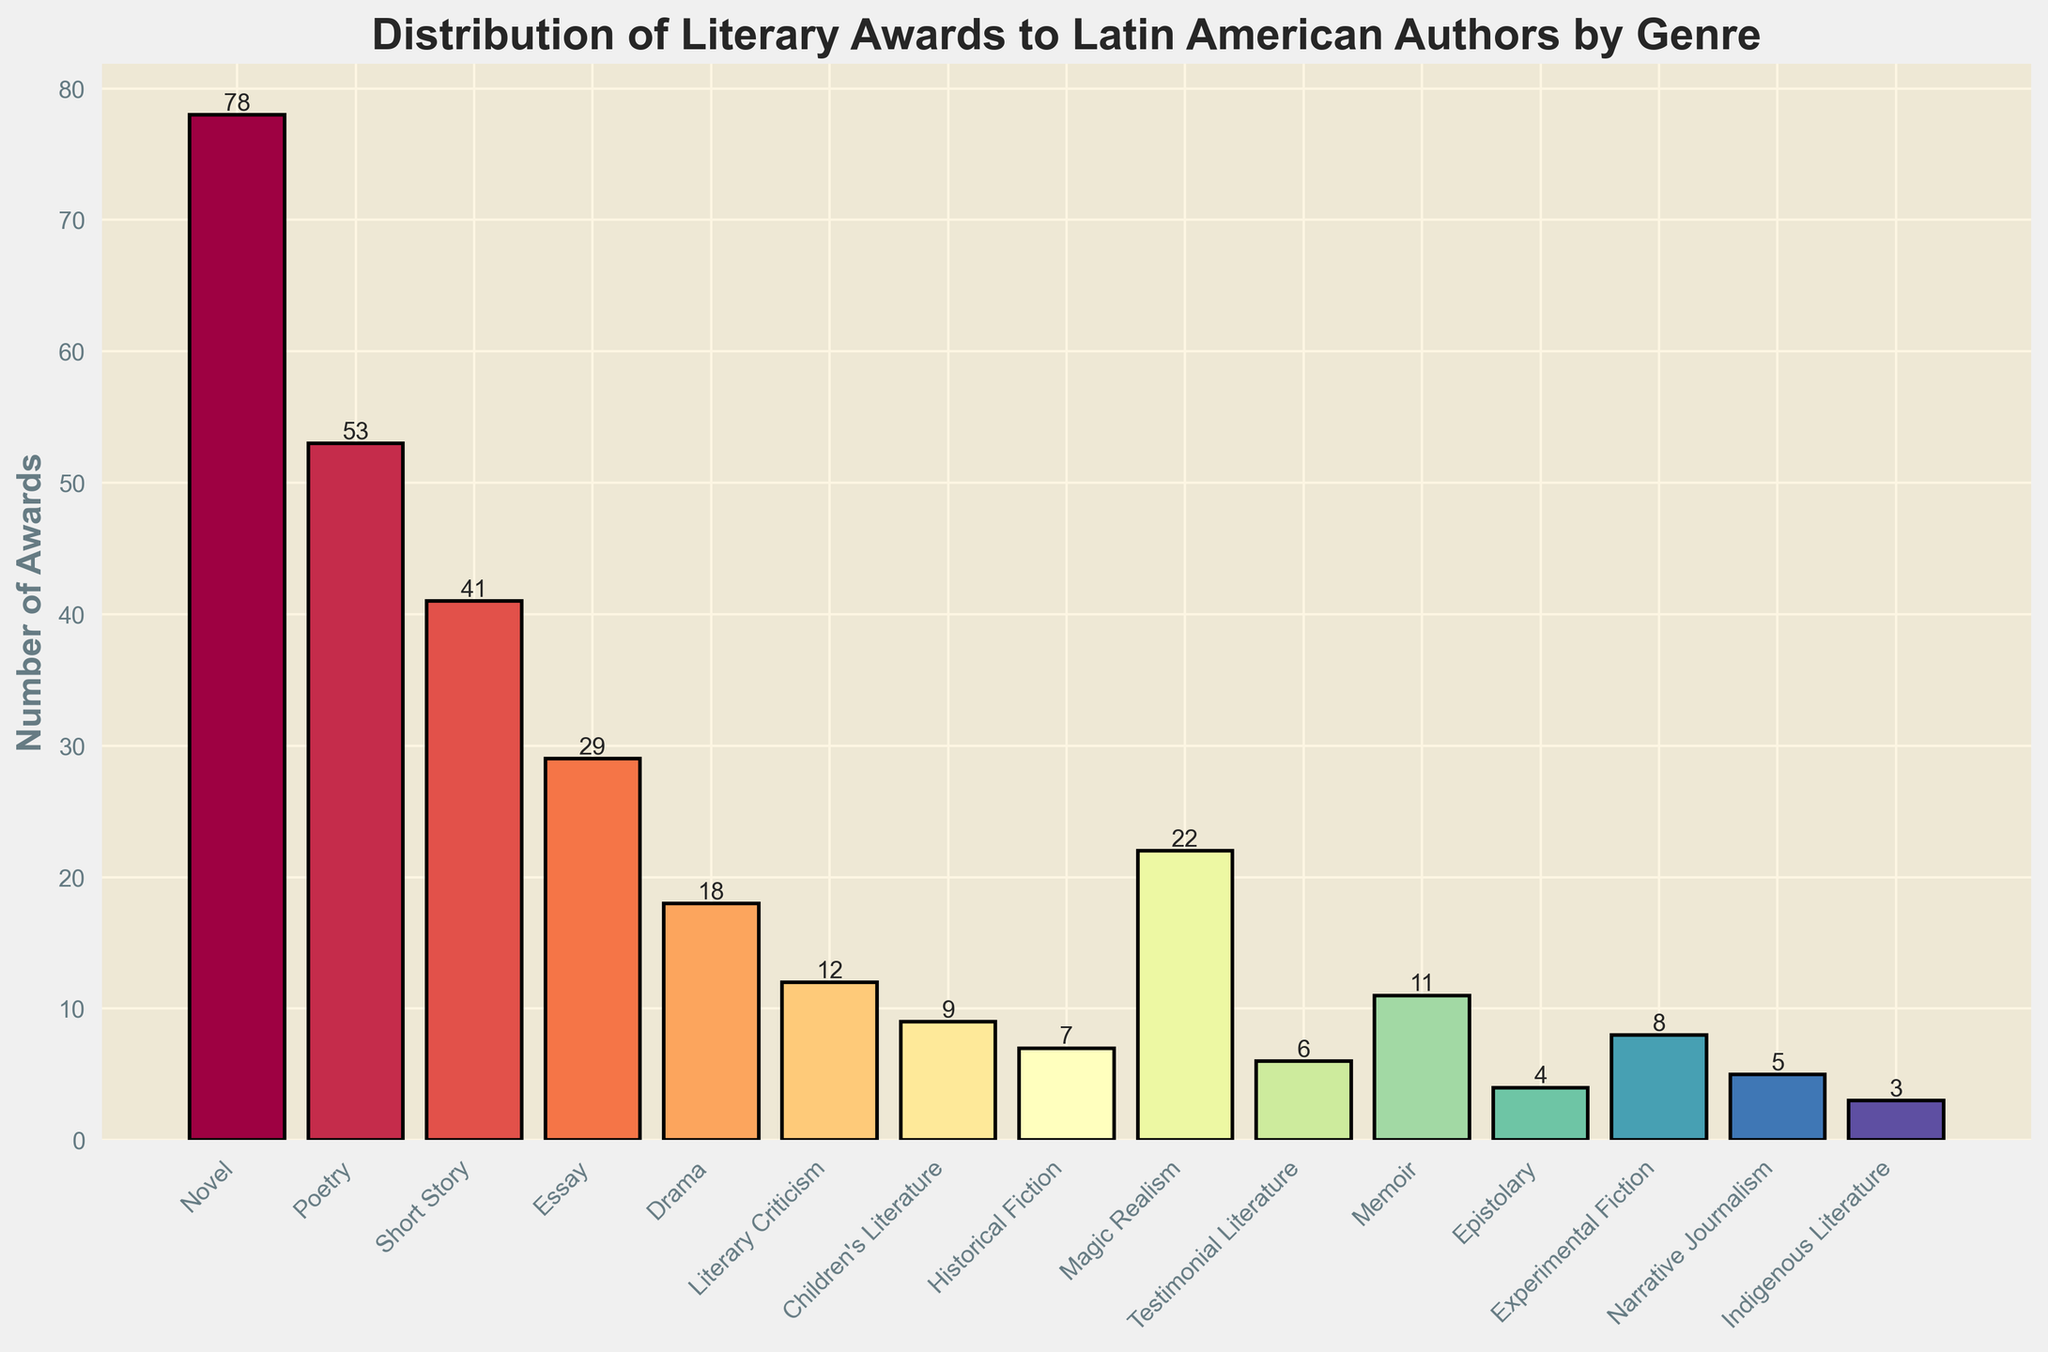What's the genre with the highest number of awards? The tallest bar in the chart represents the genre with the highest number of awards. This bar corresponds to "Novel" which has 78 awards.
Answer: Novel How many more awards does Novel have compared to Poetry? Novel has 78 awards and Poetry has 53 awards. The difference is 78 - 53 = 25.
Answer: 25 What is the total number of awards for Drama, Children's Literature, and Indigenous Literature combined? The number of awards for Drama is 18, for Children's Literature is 9, and for Indigenous Literature is 3. The sum is 18 + 9 + 3 = 30.
Answer: 30 Which genre has the smallest number of awards? The shortest bar in the chart represents the genre with the smallest number of awards. This bar corresponds to "Indigenous Literature" which has 3 awards.
Answer: Indigenous Literature Are there more awards given to Memoir or Historical Fiction? Memoir has 11 awards and Historical Fiction has 7 awards. Since 11 is greater than 7, Memoir has more awards.
Answer: Memoir What is the average number of awards given to Poetry, Short Story, and Essay? The number of awards for Poetry is 53, for Short Story is 41, and for Essay is 29. The sum is 53 + 41 + 29 = 123, and the average is 123 / 3 = 41.
Answer: 41 How many genres have received more than 20 awards? Examining the bars, "Novel", "Poetry", "Short Story", and "Magic Realism" have more than 20 awards. That makes 4 genres.
Answer: 4 Which has more awards, Experimental Fiction or Epistolary literature? Experimental Fiction has 8 awards, whereas Epistolary literature has 4 awards. Since 8 is greater than 4, Experimental Fiction has more awards.
Answer: Experimental Fiction What’s the difference between the number of awards for Short Story and Literary Criticism? Short Story has 41 awards and Literary Criticism has 12 awards. The difference is 41 - 12 = 29.
Answer: 29 What is the combined number of awards for genres having less than 10 awards? The genres are Children's Literature (9), Historical Fiction (7), Testimonial Literature (6), Memoir (11 which does not qualify), Epistolary (4), Experimental Fiction (8), Narrative Journalism (5), Indigenous Literature (3). The sum is 9 + 7 + 6 + 4 + 8 + 5 + 3 = 42.
Answer: 42 